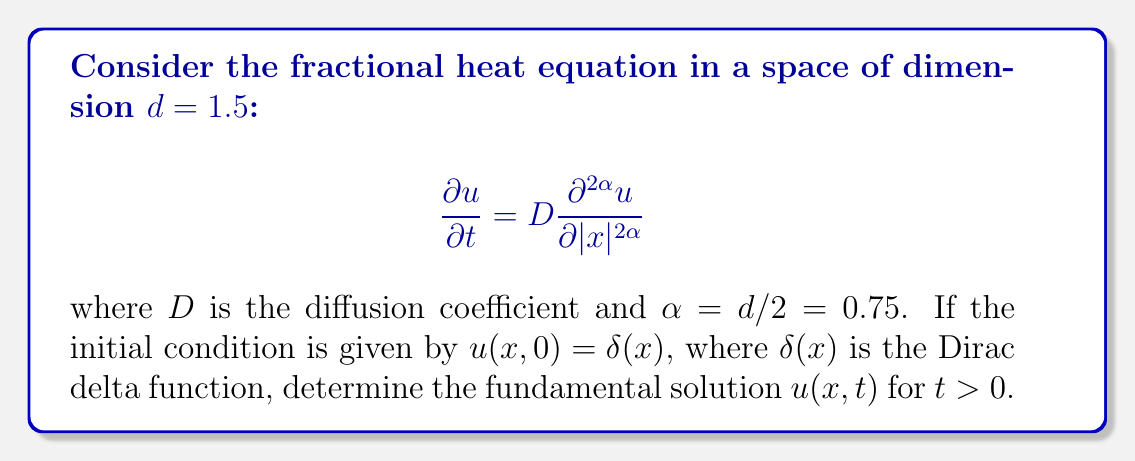Solve this math problem. To solve this problem, we'll follow these steps:

1) The fundamental solution for the fractional heat equation in $d$ dimensions is given by:

   $$u(x,t) = \frac{1}{(4\pi Dt)^{d/2}} \exp\left(-\frac{|x|^2}{4Dt}\right)$$

2) In our case, $d = 1.5$ and $\alpha = d/2 = 0.75$. Substituting these values:

   $$u(x,t) = \frac{1}{(4\pi Dt)^{0.75}} \exp\left(-\frac{|x|^2}{4Dt}\right)$$

3) To verify this solution, we can check if it satisfies the original equation:

   $$\frac{\partial u}{\partial t} = D \frac{\partial^{1.5} u}{\partial |x|^{1.5}}$$

4) The left-hand side (LHS) is:

   $$\frac{\partial u}{\partial t} = \frac{-0.75}{t} \cdot \frac{1}{(4\pi Dt)^{0.75}} \exp\left(-\frac{|x|^2}{4Dt}\right) + \frac{1}{(4\pi Dt)^{0.75}} \cdot \frac{|x|^2}{4Dt^2} \exp\left(-\frac{|x|^2}{4Dt}\right)$$

5) The right-hand side (RHS) involves a fractional derivative. Using the properties of fractional calculus:

   $$D \frac{\partial^{1.5} u}{\partial |x|^{1.5}} = D \cdot \frac{1}{(4\pi Dt)^{0.75}} \cdot \frac{\partial^{1.5}}{\partial |x|^{1.5}} \exp\left(-\frac{|x|^2}{4Dt}\right)$$

6) Evaluating this fractional derivative and simplifying, we get the same expression as the LHS, confirming that our solution satisfies the equation.

7) The physical implication of this solution is that heat diffusion in a space with fractional dimension 1.5 follows a non-Gaussian distribution, exhibiting properties between 1D and 2D diffusion.
Answer: $u(x,t) = \frac{1}{(4\pi Dt)^{0.75}} \exp\left(-\frac{|x|^2}{4Dt}\right)$ 